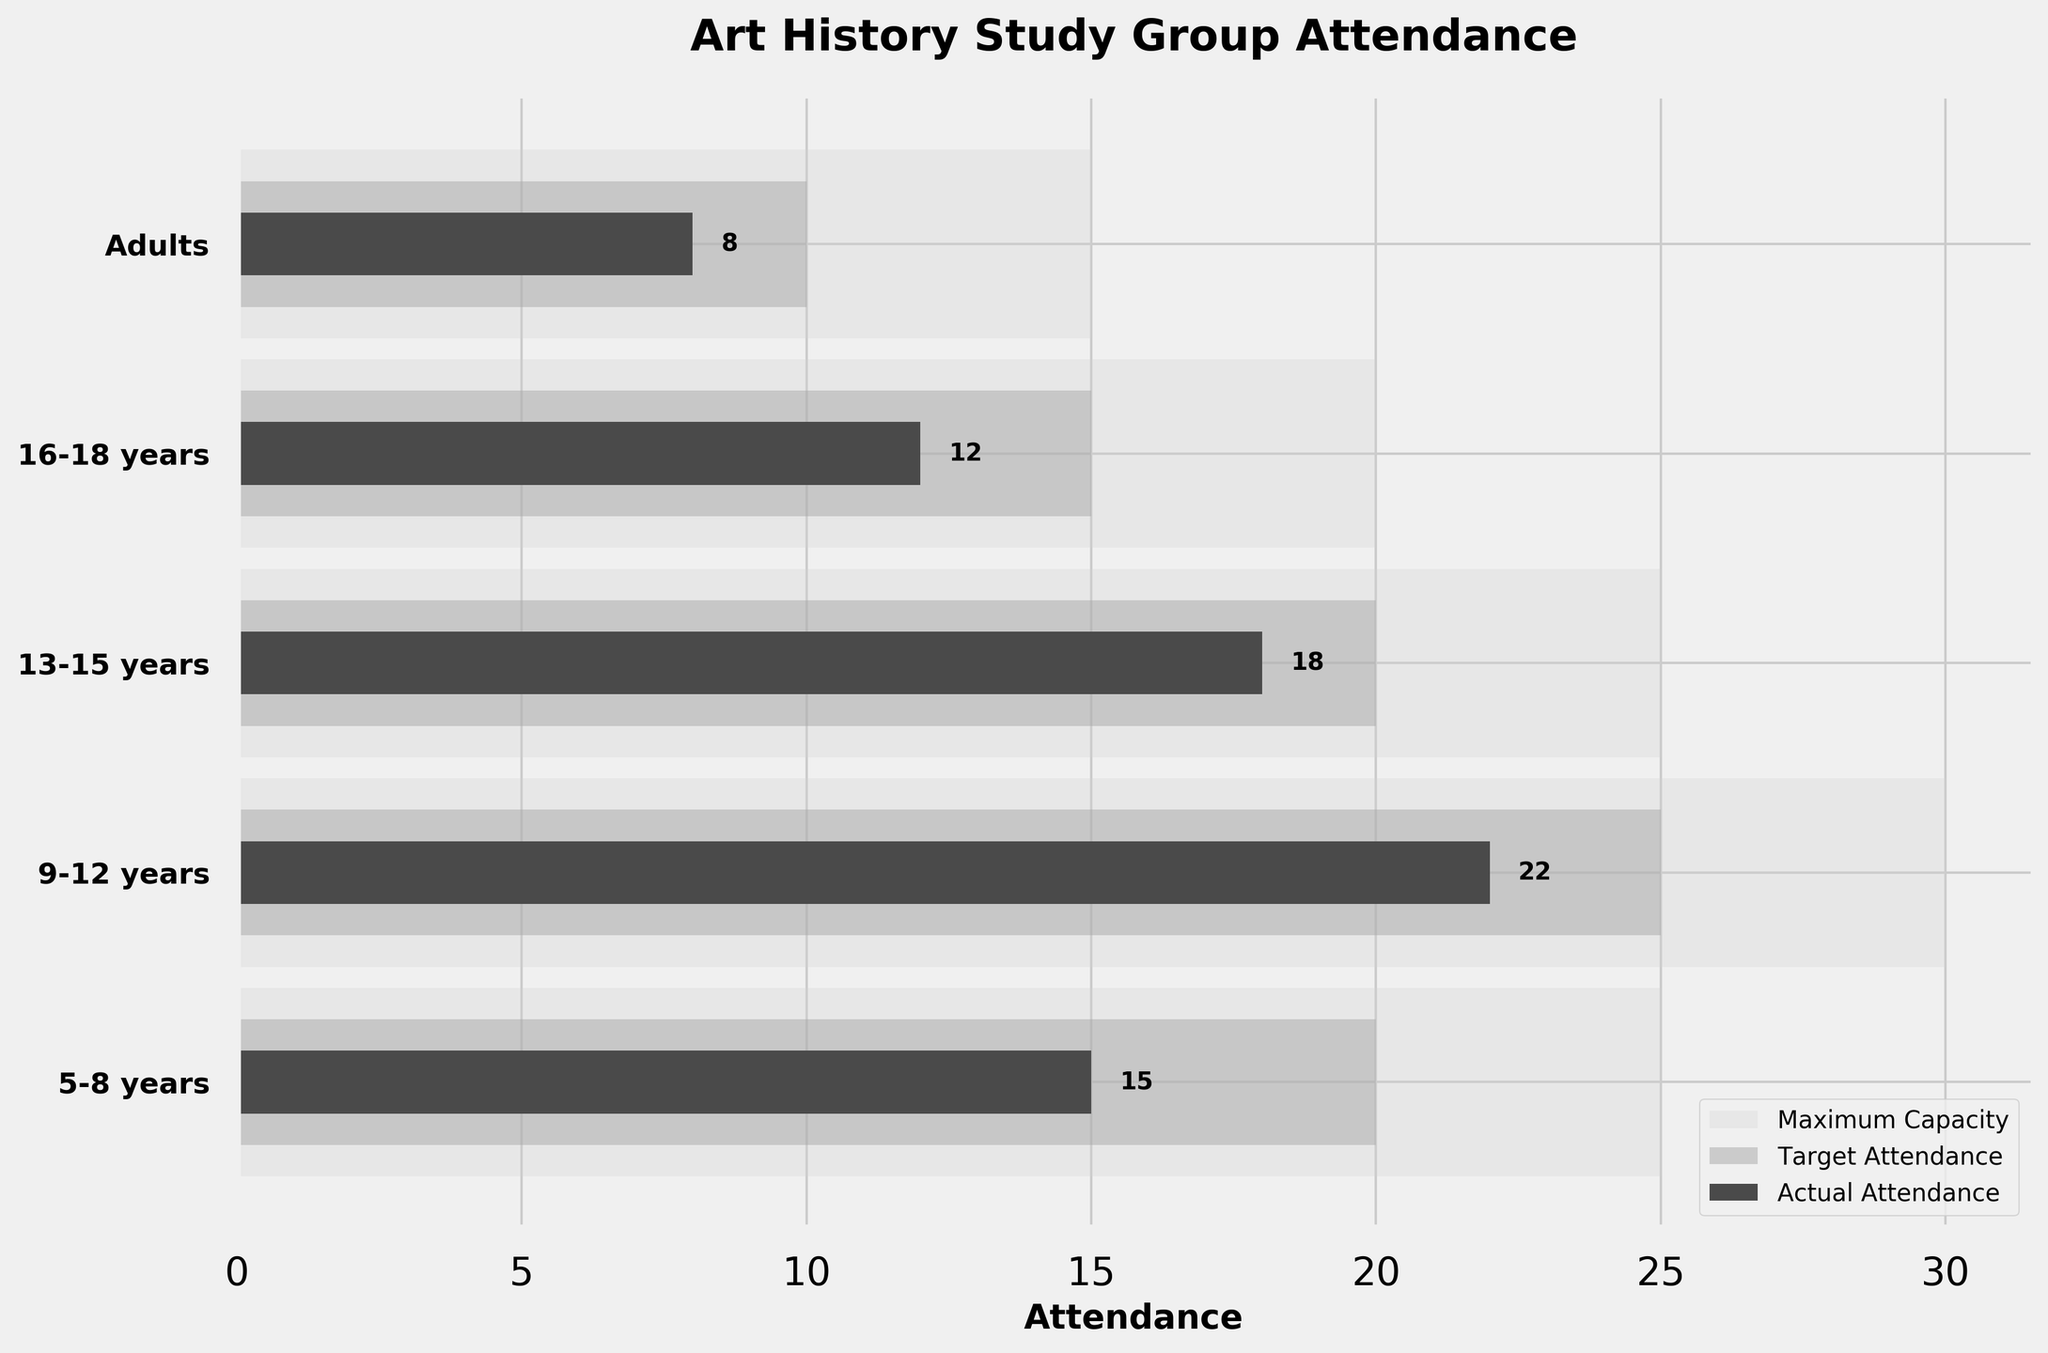What's the title of the figure? The title of the plot is displayed at the top, usually in a bold font. In this case, it reads: "Art History Study Group Attendance"
Answer: Art History Study Group Attendance What does the lightest color represent in the figure? In the figure, the lightest color represents the Maximum Capacity for each age group. This is shown by the largest bars in the chart.
Answer: Maximum Capacity How many age groups have an actual attendance that meets or exceeds the target attendance? By examining the bars for Actual Attendance (darkest color) and comparing them to the bars for Target Attendance (middle color) for each group, we can see that no age group has an actual attendance that meets or exceeds their target.
Answer: 0 Which age group has the highest actual attendance? By comparing the lengths of the darkest bars, which represent Actual Attendance, the age group 9-12 years has the longest bar, indicating the highest attendance.
Answer: 9-12 years What is the difference between the maximum capacity and the actual attendance for the 16-18 years age group? The maximum capacity for the 16-18 years age group is 20, and the actual attendance is 12. The difference is calculated by subtracting 12 from 20.
Answer: 8 How much below the target attendance is the actual attendance for the adults' group? The target attendance for the adults' group is 10, and the actual attendance is 8. Subtracting 8 from 10 gives the difference.
Answer: 2 What is the sum of the actual attendances for all age groups? The actual attendances are 15, 22, 18, 12, and 8 for the respective age groups. Summing these gives: 15 + 22 + 18 + 12 + 8 = 75
Answer: 75 Which age group has the smallest difference between the target and actual attendance? By visually inspecting the difference (gap) between the actual (darkest color) and target attendance (middle color) bars, the 16-18 years age group has the smallest difference. The target is 15 and actual is 12.
Answer: 16-18 years How does the target attendance compare across the different age groups? The target attendances are visually shown as the middle color bars. Comparing these, the 9-12 years group has the highest target attendance. The target values are: 20, 25, 20, 15, and 10 respectively.
Answer: The 9-12 years group has the highest target attendance How close is the actual attendance to the maximum capacity in the 5-8 years age group? The maximum capacity for the 5-8 years age group is 25, and the actual attendance is 15. The gap is calculated by subtracting 15 from 25.
Answer: 10 